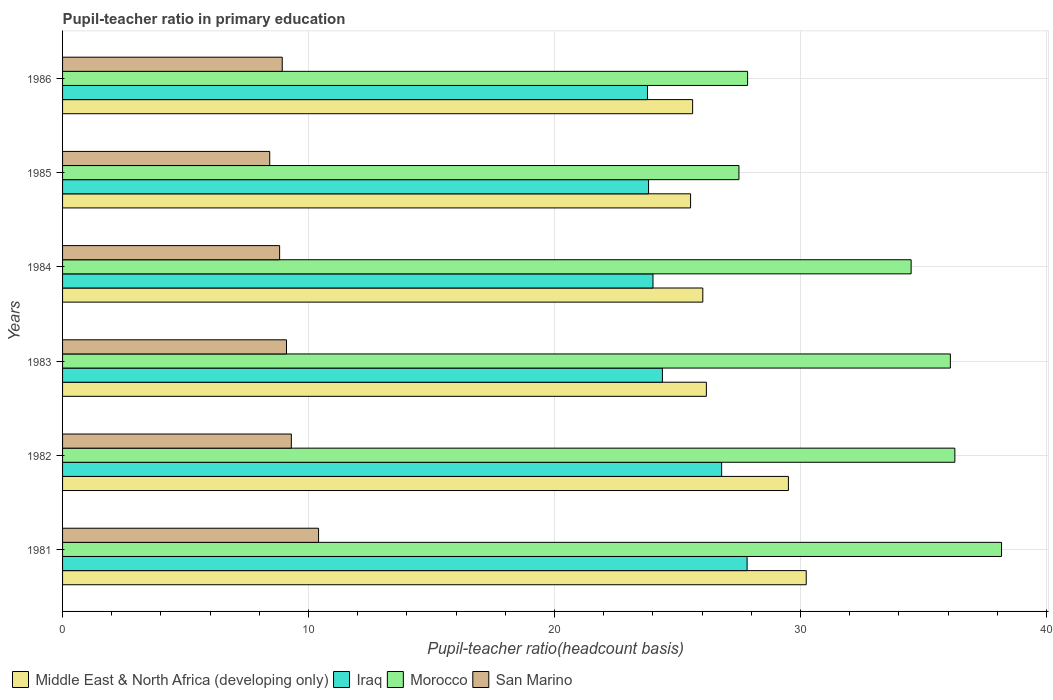How many different coloured bars are there?
Offer a terse response. 4. Are the number of bars per tick equal to the number of legend labels?
Your answer should be compact. Yes. Are the number of bars on each tick of the Y-axis equal?
Your answer should be compact. Yes. In how many cases, is the number of bars for a given year not equal to the number of legend labels?
Keep it short and to the point. 0. What is the pupil-teacher ratio in primary education in Morocco in 1986?
Keep it short and to the point. 27.85. Across all years, what is the maximum pupil-teacher ratio in primary education in San Marino?
Provide a succinct answer. 10.41. Across all years, what is the minimum pupil-teacher ratio in primary education in Morocco?
Make the answer very short. 27.5. What is the total pupil-teacher ratio in primary education in Middle East & North Africa (developing only) in the graph?
Your response must be concise. 163.08. What is the difference between the pupil-teacher ratio in primary education in Iraq in 1982 and that in 1983?
Your answer should be very brief. 2.41. What is the difference between the pupil-teacher ratio in primary education in Iraq in 1981 and the pupil-teacher ratio in primary education in Middle East & North Africa (developing only) in 1986?
Offer a terse response. 2.22. What is the average pupil-teacher ratio in primary education in Iraq per year?
Ensure brevity in your answer.  25.1. In the year 1981, what is the difference between the pupil-teacher ratio in primary education in Morocco and pupil-teacher ratio in primary education in Middle East & North Africa (developing only)?
Ensure brevity in your answer.  7.94. What is the ratio of the pupil-teacher ratio in primary education in Iraq in 1981 to that in 1985?
Give a very brief answer. 1.17. Is the pupil-teacher ratio in primary education in Morocco in 1984 less than that in 1986?
Give a very brief answer. No. What is the difference between the highest and the second highest pupil-teacher ratio in primary education in San Marino?
Offer a terse response. 1.11. What is the difference between the highest and the lowest pupil-teacher ratio in primary education in Morocco?
Keep it short and to the point. 10.68. In how many years, is the pupil-teacher ratio in primary education in Iraq greater than the average pupil-teacher ratio in primary education in Iraq taken over all years?
Make the answer very short. 2. Is the sum of the pupil-teacher ratio in primary education in San Marino in 1981 and 1983 greater than the maximum pupil-teacher ratio in primary education in Middle East & North Africa (developing only) across all years?
Provide a short and direct response. No. What does the 3rd bar from the top in 1982 represents?
Your response must be concise. Iraq. What does the 1st bar from the bottom in 1985 represents?
Provide a short and direct response. Middle East & North Africa (developing only). What is the difference between two consecutive major ticks on the X-axis?
Give a very brief answer. 10. Does the graph contain grids?
Give a very brief answer. Yes. How are the legend labels stacked?
Give a very brief answer. Horizontal. What is the title of the graph?
Give a very brief answer. Pupil-teacher ratio in primary education. What is the label or title of the X-axis?
Offer a very short reply. Pupil-teacher ratio(headcount basis). What is the Pupil-teacher ratio(headcount basis) in Middle East & North Africa (developing only) in 1981?
Provide a succinct answer. 30.23. What is the Pupil-teacher ratio(headcount basis) in Iraq in 1981?
Your answer should be very brief. 27.83. What is the Pupil-teacher ratio(headcount basis) in Morocco in 1981?
Ensure brevity in your answer.  38.17. What is the Pupil-teacher ratio(headcount basis) in San Marino in 1981?
Provide a succinct answer. 10.41. What is the Pupil-teacher ratio(headcount basis) in Middle East & North Africa (developing only) in 1982?
Ensure brevity in your answer.  29.51. What is the Pupil-teacher ratio(headcount basis) of Iraq in 1982?
Offer a terse response. 26.79. What is the Pupil-teacher ratio(headcount basis) of Morocco in 1982?
Your response must be concise. 36.27. What is the Pupil-teacher ratio(headcount basis) in San Marino in 1982?
Provide a short and direct response. 9.3. What is the Pupil-teacher ratio(headcount basis) of Middle East & North Africa (developing only) in 1983?
Your response must be concise. 26.17. What is the Pupil-teacher ratio(headcount basis) in Iraq in 1983?
Give a very brief answer. 24.39. What is the Pupil-teacher ratio(headcount basis) of Morocco in 1983?
Ensure brevity in your answer.  36.09. What is the Pupil-teacher ratio(headcount basis) of San Marino in 1983?
Give a very brief answer. 9.1. What is the Pupil-teacher ratio(headcount basis) in Middle East & North Africa (developing only) in 1984?
Offer a terse response. 26.03. What is the Pupil-teacher ratio(headcount basis) in Iraq in 1984?
Offer a very short reply. 24. What is the Pupil-teacher ratio(headcount basis) of Morocco in 1984?
Your answer should be very brief. 34.5. What is the Pupil-teacher ratio(headcount basis) in San Marino in 1984?
Ensure brevity in your answer.  8.82. What is the Pupil-teacher ratio(headcount basis) in Middle East & North Africa (developing only) in 1985?
Your answer should be very brief. 25.53. What is the Pupil-teacher ratio(headcount basis) of Iraq in 1985?
Give a very brief answer. 23.82. What is the Pupil-teacher ratio(headcount basis) in Morocco in 1985?
Give a very brief answer. 27.5. What is the Pupil-teacher ratio(headcount basis) of San Marino in 1985?
Offer a very short reply. 8.42. What is the Pupil-teacher ratio(headcount basis) in Middle East & North Africa (developing only) in 1986?
Provide a succinct answer. 25.61. What is the Pupil-teacher ratio(headcount basis) of Iraq in 1986?
Provide a short and direct response. 23.78. What is the Pupil-teacher ratio(headcount basis) in Morocco in 1986?
Give a very brief answer. 27.85. What is the Pupil-teacher ratio(headcount basis) of San Marino in 1986?
Your answer should be compact. 8.93. Across all years, what is the maximum Pupil-teacher ratio(headcount basis) of Middle East & North Africa (developing only)?
Your answer should be very brief. 30.23. Across all years, what is the maximum Pupil-teacher ratio(headcount basis) in Iraq?
Make the answer very short. 27.83. Across all years, what is the maximum Pupil-teacher ratio(headcount basis) in Morocco?
Make the answer very short. 38.17. Across all years, what is the maximum Pupil-teacher ratio(headcount basis) of San Marino?
Your response must be concise. 10.41. Across all years, what is the minimum Pupil-teacher ratio(headcount basis) of Middle East & North Africa (developing only)?
Give a very brief answer. 25.53. Across all years, what is the minimum Pupil-teacher ratio(headcount basis) of Iraq?
Ensure brevity in your answer.  23.78. Across all years, what is the minimum Pupil-teacher ratio(headcount basis) of Morocco?
Your answer should be very brief. 27.5. Across all years, what is the minimum Pupil-teacher ratio(headcount basis) in San Marino?
Offer a terse response. 8.42. What is the total Pupil-teacher ratio(headcount basis) of Middle East & North Africa (developing only) in the graph?
Provide a succinct answer. 163.08. What is the total Pupil-teacher ratio(headcount basis) of Iraq in the graph?
Keep it short and to the point. 150.61. What is the total Pupil-teacher ratio(headcount basis) in Morocco in the graph?
Offer a very short reply. 200.38. What is the total Pupil-teacher ratio(headcount basis) in San Marino in the graph?
Make the answer very short. 54.99. What is the difference between the Pupil-teacher ratio(headcount basis) in Middle East & North Africa (developing only) in 1981 and that in 1982?
Offer a very short reply. 0.72. What is the difference between the Pupil-teacher ratio(headcount basis) in Iraq in 1981 and that in 1982?
Offer a terse response. 1.04. What is the difference between the Pupil-teacher ratio(headcount basis) of Morocco in 1981 and that in 1982?
Your answer should be very brief. 1.9. What is the difference between the Pupil-teacher ratio(headcount basis) of San Marino in 1981 and that in 1982?
Give a very brief answer. 1.11. What is the difference between the Pupil-teacher ratio(headcount basis) of Middle East & North Africa (developing only) in 1981 and that in 1983?
Give a very brief answer. 4.06. What is the difference between the Pupil-teacher ratio(headcount basis) of Iraq in 1981 and that in 1983?
Your answer should be compact. 3.44. What is the difference between the Pupil-teacher ratio(headcount basis) of Morocco in 1981 and that in 1983?
Ensure brevity in your answer.  2.08. What is the difference between the Pupil-teacher ratio(headcount basis) of San Marino in 1981 and that in 1983?
Keep it short and to the point. 1.3. What is the difference between the Pupil-teacher ratio(headcount basis) in Middle East & North Africa (developing only) in 1981 and that in 1984?
Your response must be concise. 4.2. What is the difference between the Pupil-teacher ratio(headcount basis) of Iraq in 1981 and that in 1984?
Keep it short and to the point. 3.83. What is the difference between the Pupil-teacher ratio(headcount basis) of Morocco in 1981 and that in 1984?
Make the answer very short. 3.68. What is the difference between the Pupil-teacher ratio(headcount basis) of San Marino in 1981 and that in 1984?
Your answer should be compact. 1.58. What is the difference between the Pupil-teacher ratio(headcount basis) of Middle East & North Africa (developing only) in 1981 and that in 1985?
Ensure brevity in your answer.  4.7. What is the difference between the Pupil-teacher ratio(headcount basis) in Iraq in 1981 and that in 1985?
Make the answer very short. 4.01. What is the difference between the Pupil-teacher ratio(headcount basis) in Morocco in 1981 and that in 1985?
Offer a very short reply. 10.68. What is the difference between the Pupil-teacher ratio(headcount basis) in San Marino in 1981 and that in 1985?
Give a very brief answer. 1.99. What is the difference between the Pupil-teacher ratio(headcount basis) of Middle East & North Africa (developing only) in 1981 and that in 1986?
Provide a short and direct response. 4.62. What is the difference between the Pupil-teacher ratio(headcount basis) of Iraq in 1981 and that in 1986?
Keep it short and to the point. 4.05. What is the difference between the Pupil-teacher ratio(headcount basis) of Morocco in 1981 and that in 1986?
Your response must be concise. 10.32. What is the difference between the Pupil-teacher ratio(headcount basis) of San Marino in 1981 and that in 1986?
Offer a terse response. 1.48. What is the difference between the Pupil-teacher ratio(headcount basis) in Middle East & North Africa (developing only) in 1982 and that in 1983?
Provide a succinct answer. 3.33. What is the difference between the Pupil-teacher ratio(headcount basis) in Iraq in 1982 and that in 1983?
Offer a terse response. 2.41. What is the difference between the Pupil-teacher ratio(headcount basis) in Morocco in 1982 and that in 1983?
Ensure brevity in your answer.  0.18. What is the difference between the Pupil-teacher ratio(headcount basis) of San Marino in 1982 and that in 1983?
Your response must be concise. 0.2. What is the difference between the Pupil-teacher ratio(headcount basis) of Middle East & North Africa (developing only) in 1982 and that in 1984?
Keep it short and to the point. 3.48. What is the difference between the Pupil-teacher ratio(headcount basis) of Iraq in 1982 and that in 1984?
Your response must be concise. 2.79. What is the difference between the Pupil-teacher ratio(headcount basis) of Morocco in 1982 and that in 1984?
Keep it short and to the point. 1.78. What is the difference between the Pupil-teacher ratio(headcount basis) in San Marino in 1982 and that in 1984?
Provide a short and direct response. 0.48. What is the difference between the Pupil-teacher ratio(headcount basis) in Middle East & North Africa (developing only) in 1982 and that in 1985?
Your response must be concise. 3.98. What is the difference between the Pupil-teacher ratio(headcount basis) of Iraq in 1982 and that in 1985?
Your answer should be very brief. 2.97. What is the difference between the Pupil-teacher ratio(headcount basis) in Morocco in 1982 and that in 1985?
Give a very brief answer. 8.78. What is the difference between the Pupil-teacher ratio(headcount basis) of San Marino in 1982 and that in 1985?
Provide a succinct answer. 0.88. What is the difference between the Pupil-teacher ratio(headcount basis) in Middle East & North Africa (developing only) in 1982 and that in 1986?
Offer a very short reply. 3.89. What is the difference between the Pupil-teacher ratio(headcount basis) in Iraq in 1982 and that in 1986?
Offer a terse response. 3.01. What is the difference between the Pupil-teacher ratio(headcount basis) of Morocco in 1982 and that in 1986?
Keep it short and to the point. 8.42. What is the difference between the Pupil-teacher ratio(headcount basis) of San Marino in 1982 and that in 1986?
Offer a very short reply. 0.37. What is the difference between the Pupil-teacher ratio(headcount basis) in Middle East & North Africa (developing only) in 1983 and that in 1984?
Your answer should be compact. 0.15. What is the difference between the Pupil-teacher ratio(headcount basis) of Iraq in 1983 and that in 1984?
Offer a terse response. 0.38. What is the difference between the Pupil-teacher ratio(headcount basis) in Morocco in 1983 and that in 1984?
Make the answer very short. 1.6. What is the difference between the Pupil-teacher ratio(headcount basis) in San Marino in 1983 and that in 1984?
Your response must be concise. 0.28. What is the difference between the Pupil-teacher ratio(headcount basis) in Middle East & North Africa (developing only) in 1983 and that in 1985?
Keep it short and to the point. 0.64. What is the difference between the Pupil-teacher ratio(headcount basis) in Iraq in 1983 and that in 1985?
Offer a very short reply. 0.56. What is the difference between the Pupil-teacher ratio(headcount basis) in Morocco in 1983 and that in 1985?
Provide a short and direct response. 8.59. What is the difference between the Pupil-teacher ratio(headcount basis) in San Marino in 1983 and that in 1985?
Make the answer very short. 0.68. What is the difference between the Pupil-teacher ratio(headcount basis) of Middle East & North Africa (developing only) in 1983 and that in 1986?
Your answer should be compact. 0.56. What is the difference between the Pupil-teacher ratio(headcount basis) in Iraq in 1983 and that in 1986?
Give a very brief answer. 0.61. What is the difference between the Pupil-teacher ratio(headcount basis) in Morocco in 1983 and that in 1986?
Offer a very short reply. 8.24. What is the difference between the Pupil-teacher ratio(headcount basis) of San Marino in 1983 and that in 1986?
Ensure brevity in your answer.  0.17. What is the difference between the Pupil-teacher ratio(headcount basis) of Middle East & North Africa (developing only) in 1984 and that in 1985?
Your answer should be compact. 0.5. What is the difference between the Pupil-teacher ratio(headcount basis) in Iraq in 1984 and that in 1985?
Offer a terse response. 0.18. What is the difference between the Pupil-teacher ratio(headcount basis) of Morocco in 1984 and that in 1985?
Your answer should be very brief. 7. What is the difference between the Pupil-teacher ratio(headcount basis) of San Marino in 1984 and that in 1985?
Keep it short and to the point. 0.4. What is the difference between the Pupil-teacher ratio(headcount basis) of Middle East & North Africa (developing only) in 1984 and that in 1986?
Keep it short and to the point. 0.41. What is the difference between the Pupil-teacher ratio(headcount basis) of Iraq in 1984 and that in 1986?
Make the answer very short. 0.22. What is the difference between the Pupil-teacher ratio(headcount basis) in Morocco in 1984 and that in 1986?
Offer a terse response. 6.65. What is the difference between the Pupil-teacher ratio(headcount basis) in San Marino in 1984 and that in 1986?
Provide a short and direct response. -0.11. What is the difference between the Pupil-teacher ratio(headcount basis) in Middle East & North Africa (developing only) in 1985 and that in 1986?
Your answer should be compact. -0.08. What is the difference between the Pupil-teacher ratio(headcount basis) of Iraq in 1985 and that in 1986?
Provide a succinct answer. 0.04. What is the difference between the Pupil-teacher ratio(headcount basis) in Morocco in 1985 and that in 1986?
Your answer should be very brief. -0.35. What is the difference between the Pupil-teacher ratio(headcount basis) of San Marino in 1985 and that in 1986?
Give a very brief answer. -0.51. What is the difference between the Pupil-teacher ratio(headcount basis) of Middle East & North Africa (developing only) in 1981 and the Pupil-teacher ratio(headcount basis) of Iraq in 1982?
Give a very brief answer. 3.44. What is the difference between the Pupil-teacher ratio(headcount basis) in Middle East & North Africa (developing only) in 1981 and the Pupil-teacher ratio(headcount basis) in Morocco in 1982?
Offer a terse response. -6.04. What is the difference between the Pupil-teacher ratio(headcount basis) of Middle East & North Africa (developing only) in 1981 and the Pupil-teacher ratio(headcount basis) of San Marino in 1982?
Keep it short and to the point. 20.93. What is the difference between the Pupil-teacher ratio(headcount basis) of Iraq in 1981 and the Pupil-teacher ratio(headcount basis) of Morocco in 1982?
Make the answer very short. -8.44. What is the difference between the Pupil-teacher ratio(headcount basis) of Iraq in 1981 and the Pupil-teacher ratio(headcount basis) of San Marino in 1982?
Your answer should be very brief. 18.53. What is the difference between the Pupil-teacher ratio(headcount basis) in Morocco in 1981 and the Pupil-teacher ratio(headcount basis) in San Marino in 1982?
Offer a very short reply. 28.87. What is the difference between the Pupil-teacher ratio(headcount basis) of Middle East & North Africa (developing only) in 1981 and the Pupil-teacher ratio(headcount basis) of Iraq in 1983?
Make the answer very short. 5.85. What is the difference between the Pupil-teacher ratio(headcount basis) of Middle East & North Africa (developing only) in 1981 and the Pupil-teacher ratio(headcount basis) of Morocco in 1983?
Offer a terse response. -5.86. What is the difference between the Pupil-teacher ratio(headcount basis) of Middle East & North Africa (developing only) in 1981 and the Pupil-teacher ratio(headcount basis) of San Marino in 1983?
Provide a short and direct response. 21.13. What is the difference between the Pupil-teacher ratio(headcount basis) of Iraq in 1981 and the Pupil-teacher ratio(headcount basis) of Morocco in 1983?
Provide a succinct answer. -8.26. What is the difference between the Pupil-teacher ratio(headcount basis) of Iraq in 1981 and the Pupil-teacher ratio(headcount basis) of San Marino in 1983?
Make the answer very short. 18.73. What is the difference between the Pupil-teacher ratio(headcount basis) in Morocco in 1981 and the Pupil-teacher ratio(headcount basis) in San Marino in 1983?
Offer a terse response. 29.07. What is the difference between the Pupil-teacher ratio(headcount basis) of Middle East & North Africa (developing only) in 1981 and the Pupil-teacher ratio(headcount basis) of Iraq in 1984?
Your answer should be compact. 6.23. What is the difference between the Pupil-teacher ratio(headcount basis) of Middle East & North Africa (developing only) in 1981 and the Pupil-teacher ratio(headcount basis) of Morocco in 1984?
Ensure brevity in your answer.  -4.26. What is the difference between the Pupil-teacher ratio(headcount basis) in Middle East & North Africa (developing only) in 1981 and the Pupil-teacher ratio(headcount basis) in San Marino in 1984?
Provide a short and direct response. 21.41. What is the difference between the Pupil-teacher ratio(headcount basis) of Iraq in 1981 and the Pupil-teacher ratio(headcount basis) of Morocco in 1984?
Offer a very short reply. -6.67. What is the difference between the Pupil-teacher ratio(headcount basis) of Iraq in 1981 and the Pupil-teacher ratio(headcount basis) of San Marino in 1984?
Your answer should be very brief. 19. What is the difference between the Pupil-teacher ratio(headcount basis) of Morocco in 1981 and the Pupil-teacher ratio(headcount basis) of San Marino in 1984?
Provide a succinct answer. 29.35. What is the difference between the Pupil-teacher ratio(headcount basis) in Middle East & North Africa (developing only) in 1981 and the Pupil-teacher ratio(headcount basis) in Iraq in 1985?
Provide a short and direct response. 6.41. What is the difference between the Pupil-teacher ratio(headcount basis) in Middle East & North Africa (developing only) in 1981 and the Pupil-teacher ratio(headcount basis) in Morocco in 1985?
Keep it short and to the point. 2.74. What is the difference between the Pupil-teacher ratio(headcount basis) in Middle East & North Africa (developing only) in 1981 and the Pupil-teacher ratio(headcount basis) in San Marino in 1985?
Give a very brief answer. 21.81. What is the difference between the Pupil-teacher ratio(headcount basis) of Iraq in 1981 and the Pupil-teacher ratio(headcount basis) of Morocco in 1985?
Ensure brevity in your answer.  0.33. What is the difference between the Pupil-teacher ratio(headcount basis) in Iraq in 1981 and the Pupil-teacher ratio(headcount basis) in San Marino in 1985?
Ensure brevity in your answer.  19.41. What is the difference between the Pupil-teacher ratio(headcount basis) in Morocco in 1981 and the Pupil-teacher ratio(headcount basis) in San Marino in 1985?
Ensure brevity in your answer.  29.75. What is the difference between the Pupil-teacher ratio(headcount basis) in Middle East & North Africa (developing only) in 1981 and the Pupil-teacher ratio(headcount basis) in Iraq in 1986?
Keep it short and to the point. 6.45. What is the difference between the Pupil-teacher ratio(headcount basis) in Middle East & North Africa (developing only) in 1981 and the Pupil-teacher ratio(headcount basis) in Morocco in 1986?
Give a very brief answer. 2.38. What is the difference between the Pupil-teacher ratio(headcount basis) of Middle East & North Africa (developing only) in 1981 and the Pupil-teacher ratio(headcount basis) of San Marino in 1986?
Keep it short and to the point. 21.3. What is the difference between the Pupil-teacher ratio(headcount basis) in Iraq in 1981 and the Pupil-teacher ratio(headcount basis) in Morocco in 1986?
Your answer should be compact. -0.02. What is the difference between the Pupil-teacher ratio(headcount basis) of Iraq in 1981 and the Pupil-teacher ratio(headcount basis) of San Marino in 1986?
Provide a short and direct response. 18.9. What is the difference between the Pupil-teacher ratio(headcount basis) of Morocco in 1981 and the Pupil-teacher ratio(headcount basis) of San Marino in 1986?
Your answer should be compact. 29.24. What is the difference between the Pupil-teacher ratio(headcount basis) in Middle East & North Africa (developing only) in 1982 and the Pupil-teacher ratio(headcount basis) in Iraq in 1983?
Keep it short and to the point. 5.12. What is the difference between the Pupil-teacher ratio(headcount basis) in Middle East & North Africa (developing only) in 1982 and the Pupil-teacher ratio(headcount basis) in Morocco in 1983?
Your response must be concise. -6.58. What is the difference between the Pupil-teacher ratio(headcount basis) of Middle East & North Africa (developing only) in 1982 and the Pupil-teacher ratio(headcount basis) of San Marino in 1983?
Provide a short and direct response. 20.4. What is the difference between the Pupil-teacher ratio(headcount basis) of Iraq in 1982 and the Pupil-teacher ratio(headcount basis) of Morocco in 1983?
Offer a very short reply. -9.3. What is the difference between the Pupil-teacher ratio(headcount basis) of Iraq in 1982 and the Pupil-teacher ratio(headcount basis) of San Marino in 1983?
Your answer should be compact. 17.69. What is the difference between the Pupil-teacher ratio(headcount basis) in Morocco in 1982 and the Pupil-teacher ratio(headcount basis) in San Marino in 1983?
Provide a short and direct response. 27.17. What is the difference between the Pupil-teacher ratio(headcount basis) in Middle East & North Africa (developing only) in 1982 and the Pupil-teacher ratio(headcount basis) in Iraq in 1984?
Make the answer very short. 5.51. What is the difference between the Pupil-teacher ratio(headcount basis) in Middle East & North Africa (developing only) in 1982 and the Pupil-teacher ratio(headcount basis) in Morocco in 1984?
Offer a terse response. -4.99. What is the difference between the Pupil-teacher ratio(headcount basis) in Middle East & North Africa (developing only) in 1982 and the Pupil-teacher ratio(headcount basis) in San Marino in 1984?
Your answer should be very brief. 20.68. What is the difference between the Pupil-teacher ratio(headcount basis) of Iraq in 1982 and the Pupil-teacher ratio(headcount basis) of Morocco in 1984?
Keep it short and to the point. -7.7. What is the difference between the Pupil-teacher ratio(headcount basis) of Iraq in 1982 and the Pupil-teacher ratio(headcount basis) of San Marino in 1984?
Ensure brevity in your answer.  17.97. What is the difference between the Pupil-teacher ratio(headcount basis) in Morocco in 1982 and the Pupil-teacher ratio(headcount basis) in San Marino in 1984?
Make the answer very short. 27.45. What is the difference between the Pupil-teacher ratio(headcount basis) of Middle East & North Africa (developing only) in 1982 and the Pupil-teacher ratio(headcount basis) of Iraq in 1985?
Ensure brevity in your answer.  5.69. What is the difference between the Pupil-teacher ratio(headcount basis) of Middle East & North Africa (developing only) in 1982 and the Pupil-teacher ratio(headcount basis) of Morocco in 1985?
Ensure brevity in your answer.  2.01. What is the difference between the Pupil-teacher ratio(headcount basis) of Middle East & North Africa (developing only) in 1982 and the Pupil-teacher ratio(headcount basis) of San Marino in 1985?
Offer a very short reply. 21.09. What is the difference between the Pupil-teacher ratio(headcount basis) of Iraq in 1982 and the Pupil-teacher ratio(headcount basis) of Morocco in 1985?
Provide a succinct answer. -0.7. What is the difference between the Pupil-teacher ratio(headcount basis) in Iraq in 1982 and the Pupil-teacher ratio(headcount basis) in San Marino in 1985?
Your response must be concise. 18.37. What is the difference between the Pupil-teacher ratio(headcount basis) in Morocco in 1982 and the Pupil-teacher ratio(headcount basis) in San Marino in 1985?
Your response must be concise. 27.85. What is the difference between the Pupil-teacher ratio(headcount basis) of Middle East & North Africa (developing only) in 1982 and the Pupil-teacher ratio(headcount basis) of Iraq in 1986?
Ensure brevity in your answer.  5.73. What is the difference between the Pupil-teacher ratio(headcount basis) of Middle East & North Africa (developing only) in 1982 and the Pupil-teacher ratio(headcount basis) of Morocco in 1986?
Ensure brevity in your answer.  1.66. What is the difference between the Pupil-teacher ratio(headcount basis) of Middle East & North Africa (developing only) in 1982 and the Pupil-teacher ratio(headcount basis) of San Marino in 1986?
Offer a very short reply. 20.58. What is the difference between the Pupil-teacher ratio(headcount basis) in Iraq in 1982 and the Pupil-teacher ratio(headcount basis) in Morocco in 1986?
Offer a terse response. -1.06. What is the difference between the Pupil-teacher ratio(headcount basis) of Iraq in 1982 and the Pupil-teacher ratio(headcount basis) of San Marino in 1986?
Your answer should be very brief. 17.86. What is the difference between the Pupil-teacher ratio(headcount basis) in Morocco in 1982 and the Pupil-teacher ratio(headcount basis) in San Marino in 1986?
Your response must be concise. 27.34. What is the difference between the Pupil-teacher ratio(headcount basis) of Middle East & North Africa (developing only) in 1983 and the Pupil-teacher ratio(headcount basis) of Iraq in 1984?
Offer a terse response. 2.17. What is the difference between the Pupil-teacher ratio(headcount basis) of Middle East & North Africa (developing only) in 1983 and the Pupil-teacher ratio(headcount basis) of Morocco in 1984?
Keep it short and to the point. -8.32. What is the difference between the Pupil-teacher ratio(headcount basis) of Middle East & North Africa (developing only) in 1983 and the Pupil-teacher ratio(headcount basis) of San Marino in 1984?
Give a very brief answer. 17.35. What is the difference between the Pupil-teacher ratio(headcount basis) of Iraq in 1983 and the Pupil-teacher ratio(headcount basis) of Morocco in 1984?
Offer a terse response. -10.11. What is the difference between the Pupil-teacher ratio(headcount basis) in Iraq in 1983 and the Pupil-teacher ratio(headcount basis) in San Marino in 1984?
Keep it short and to the point. 15.56. What is the difference between the Pupil-teacher ratio(headcount basis) of Morocco in 1983 and the Pupil-teacher ratio(headcount basis) of San Marino in 1984?
Provide a succinct answer. 27.27. What is the difference between the Pupil-teacher ratio(headcount basis) in Middle East & North Africa (developing only) in 1983 and the Pupil-teacher ratio(headcount basis) in Iraq in 1985?
Your answer should be very brief. 2.35. What is the difference between the Pupil-teacher ratio(headcount basis) of Middle East & North Africa (developing only) in 1983 and the Pupil-teacher ratio(headcount basis) of Morocco in 1985?
Provide a short and direct response. -1.32. What is the difference between the Pupil-teacher ratio(headcount basis) in Middle East & North Africa (developing only) in 1983 and the Pupil-teacher ratio(headcount basis) in San Marino in 1985?
Ensure brevity in your answer.  17.75. What is the difference between the Pupil-teacher ratio(headcount basis) of Iraq in 1983 and the Pupil-teacher ratio(headcount basis) of Morocco in 1985?
Offer a terse response. -3.11. What is the difference between the Pupil-teacher ratio(headcount basis) of Iraq in 1983 and the Pupil-teacher ratio(headcount basis) of San Marino in 1985?
Your response must be concise. 15.96. What is the difference between the Pupil-teacher ratio(headcount basis) in Morocco in 1983 and the Pupil-teacher ratio(headcount basis) in San Marino in 1985?
Give a very brief answer. 27.67. What is the difference between the Pupil-teacher ratio(headcount basis) of Middle East & North Africa (developing only) in 1983 and the Pupil-teacher ratio(headcount basis) of Iraq in 1986?
Your response must be concise. 2.39. What is the difference between the Pupil-teacher ratio(headcount basis) of Middle East & North Africa (developing only) in 1983 and the Pupil-teacher ratio(headcount basis) of Morocco in 1986?
Provide a succinct answer. -1.68. What is the difference between the Pupil-teacher ratio(headcount basis) of Middle East & North Africa (developing only) in 1983 and the Pupil-teacher ratio(headcount basis) of San Marino in 1986?
Ensure brevity in your answer.  17.24. What is the difference between the Pupil-teacher ratio(headcount basis) in Iraq in 1983 and the Pupil-teacher ratio(headcount basis) in Morocco in 1986?
Ensure brevity in your answer.  -3.46. What is the difference between the Pupil-teacher ratio(headcount basis) of Iraq in 1983 and the Pupil-teacher ratio(headcount basis) of San Marino in 1986?
Your answer should be compact. 15.45. What is the difference between the Pupil-teacher ratio(headcount basis) in Morocco in 1983 and the Pupil-teacher ratio(headcount basis) in San Marino in 1986?
Your answer should be compact. 27.16. What is the difference between the Pupil-teacher ratio(headcount basis) in Middle East & North Africa (developing only) in 1984 and the Pupil-teacher ratio(headcount basis) in Iraq in 1985?
Keep it short and to the point. 2.21. What is the difference between the Pupil-teacher ratio(headcount basis) in Middle East & North Africa (developing only) in 1984 and the Pupil-teacher ratio(headcount basis) in Morocco in 1985?
Provide a succinct answer. -1.47. What is the difference between the Pupil-teacher ratio(headcount basis) of Middle East & North Africa (developing only) in 1984 and the Pupil-teacher ratio(headcount basis) of San Marino in 1985?
Make the answer very short. 17.61. What is the difference between the Pupil-teacher ratio(headcount basis) in Iraq in 1984 and the Pupil-teacher ratio(headcount basis) in Morocco in 1985?
Your answer should be very brief. -3.49. What is the difference between the Pupil-teacher ratio(headcount basis) of Iraq in 1984 and the Pupil-teacher ratio(headcount basis) of San Marino in 1985?
Your answer should be compact. 15.58. What is the difference between the Pupil-teacher ratio(headcount basis) of Morocco in 1984 and the Pupil-teacher ratio(headcount basis) of San Marino in 1985?
Your answer should be compact. 26.07. What is the difference between the Pupil-teacher ratio(headcount basis) in Middle East & North Africa (developing only) in 1984 and the Pupil-teacher ratio(headcount basis) in Iraq in 1986?
Give a very brief answer. 2.25. What is the difference between the Pupil-teacher ratio(headcount basis) in Middle East & North Africa (developing only) in 1984 and the Pupil-teacher ratio(headcount basis) in Morocco in 1986?
Your answer should be compact. -1.82. What is the difference between the Pupil-teacher ratio(headcount basis) in Middle East & North Africa (developing only) in 1984 and the Pupil-teacher ratio(headcount basis) in San Marino in 1986?
Provide a succinct answer. 17.1. What is the difference between the Pupil-teacher ratio(headcount basis) in Iraq in 1984 and the Pupil-teacher ratio(headcount basis) in Morocco in 1986?
Make the answer very short. -3.85. What is the difference between the Pupil-teacher ratio(headcount basis) of Iraq in 1984 and the Pupil-teacher ratio(headcount basis) of San Marino in 1986?
Keep it short and to the point. 15.07. What is the difference between the Pupil-teacher ratio(headcount basis) in Morocco in 1984 and the Pupil-teacher ratio(headcount basis) in San Marino in 1986?
Provide a short and direct response. 25.57. What is the difference between the Pupil-teacher ratio(headcount basis) of Middle East & North Africa (developing only) in 1985 and the Pupil-teacher ratio(headcount basis) of Iraq in 1986?
Keep it short and to the point. 1.75. What is the difference between the Pupil-teacher ratio(headcount basis) in Middle East & North Africa (developing only) in 1985 and the Pupil-teacher ratio(headcount basis) in Morocco in 1986?
Make the answer very short. -2.32. What is the difference between the Pupil-teacher ratio(headcount basis) in Middle East & North Africa (developing only) in 1985 and the Pupil-teacher ratio(headcount basis) in San Marino in 1986?
Ensure brevity in your answer.  16.6. What is the difference between the Pupil-teacher ratio(headcount basis) of Iraq in 1985 and the Pupil-teacher ratio(headcount basis) of Morocco in 1986?
Keep it short and to the point. -4.03. What is the difference between the Pupil-teacher ratio(headcount basis) in Iraq in 1985 and the Pupil-teacher ratio(headcount basis) in San Marino in 1986?
Your response must be concise. 14.89. What is the difference between the Pupil-teacher ratio(headcount basis) of Morocco in 1985 and the Pupil-teacher ratio(headcount basis) of San Marino in 1986?
Your answer should be compact. 18.57. What is the average Pupil-teacher ratio(headcount basis) in Middle East & North Africa (developing only) per year?
Provide a short and direct response. 27.18. What is the average Pupil-teacher ratio(headcount basis) in Iraq per year?
Provide a short and direct response. 25.1. What is the average Pupil-teacher ratio(headcount basis) of Morocco per year?
Provide a succinct answer. 33.4. What is the average Pupil-teacher ratio(headcount basis) in San Marino per year?
Offer a terse response. 9.16. In the year 1981, what is the difference between the Pupil-teacher ratio(headcount basis) of Middle East & North Africa (developing only) and Pupil-teacher ratio(headcount basis) of Iraq?
Make the answer very short. 2.4. In the year 1981, what is the difference between the Pupil-teacher ratio(headcount basis) of Middle East & North Africa (developing only) and Pupil-teacher ratio(headcount basis) of Morocco?
Your response must be concise. -7.94. In the year 1981, what is the difference between the Pupil-teacher ratio(headcount basis) of Middle East & North Africa (developing only) and Pupil-teacher ratio(headcount basis) of San Marino?
Your answer should be very brief. 19.83. In the year 1981, what is the difference between the Pupil-teacher ratio(headcount basis) of Iraq and Pupil-teacher ratio(headcount basis) of Morocco?
Your response must be concise. -10.34. In the year 1981, what is the difference between the Pupil-teacher ratio(headcount basis) in Iraq and Pupil-teacher ratio(headcount basis) in San Marino?
Offer a very short reply. 17.42. In the year 1981, what is the difference between the Pupil-teacher ratio(headcount basis) in Morocco and Pupil-teacher ratio(headcount basis) in San Marino?
Your answer should be compact. 27.77. In the year 1982, what is the difference between the Pupil-teacher ratio(headcount basis) of Middle East & North Africa (developing only) and Pupil-teacher ratio(headcount basis) of Iraq?
Make the answer very short. 2.71. In the year 1982, what is the difference between the Pupil-teacher ratio(headcount basis) of Middle East & North Africa (developing only) and Pupil-teacher ratio(headcount basis) of Morocco?
Offer a very short reply. -6.77. In the year 1982, what is the difference between the Pupil-teacher ratio(headcount basis) of Middle East & North Africa (developing only) and Pupil-teacher ratio(headcount basis) of San Marino?
Keep it short and to the point. 20.21. In the year 1982, what is the difference between the Pupil-teacher ratio(headcount basis) of Iraq and Pupil-teacher ratio(headcount basis) of Morocco?
Your answer should be very brief. -9.48. In the year 1982, what is the difference between the Pupil-teacher ratio(headcount basis) in Iraq and Pupil-teacher ratio(headcount basis) in San Marino?
Offer a very short reply. 17.49. In the year 1982, what is the difference between the Pupil-teacher ratio(headcount basis) of Morocco and Pupil-teacher ratio(headcount basis) of San Marino?
Your response must be concise. 26.97. In the year 1983, what is the difference between the Pupil-teacher ratio(headcount basis) of Middle East & North Africa (developing only) and Pupil-teacher ratio(headcount basis) of Iraq?
Your answer should be compact. 1.79. In the year 1983, what is the difference between the Pupil-teacher ratio(headcount basis) in Middle East & North Africa (developing only) and Pupil-teacher ratio(headcount basis) in Morocco?
Ensure brevity in your answer.  -9.92. In the year 1983, what is the difference between the Pupil-teacher ratio(headcount basis) of Middle East & North Africa (developing only) and Pupil-teacher ratio(headcount basis) of San Marino?
Your answer should be compact. 17.07. In the year 1983, what is the difference between the Pupil-teacher ratio(headcount basis) in Iraq and Pupil-teacher ratio(headcount basis) in Morocco?
Your answer should be compact. -11.71. In the year 1983, what is the difference between the Pupil-teacher ratio(headcount basis) in Iraq and Pupil-teacher ratio(headcount basis) in San Marino?
Your answer should be very brief. 15.28. In the year 1983, what is the difference between the Pupil-teacher ratio(headcount basis) in Morocco and Pupil-teacher ratio(headcount basis) in San Marino?
Keep it short and to the point. 26.99. In the year 1984, what is the difference between the Pupil-teacher ratio(headcount basis) of Middle East & North Africa (developing only) and Pupil-teacher ratio(headcount basis) of Iraq?
Offer a very short reply. 2.03. In the year 1984, what is the difference between the Pupil-teacher ratio(headcount basis) in Middle East & North Africa (developing only) and Pupil-teacher ratio(headcount basis) in Morocco?
Offer a very short reply. -8.47. In the year 1984, what is the difference between the Pupil-teacher ratio(headcount basis) of Middle East & North Africa (developing only) and Pupil-teacher ratio(headcount basis) of San Marino?
Your answer should be compact. 17.2. In the year 1984, what is the difference between the Pupil-teacher ratio(headcount basis) in Iraq and Pupil-teacher ratio(headcount basis) in Morocco?
Provide a succinct answer. -10.49. In the year 1984, what is the difference between the Pupil-teacher ratio(headcount basis) in Iraq and Pupil-teacher ratio(headcount basis) in San Marino?
Ensure brevity in your answer.  15.18. In the year 1984, what is the difference between the Pupil-teacher ratio(headcount basis) in Morocco and Pupil-teacher ratio(headcount basis) in San Marino?
Your response must be concise. 25.67. In the year 1985, what is the difference between the Pupil-teacher ratio(headcount basis) in Middle East & North Africa (developing only) and Pupil-teacher ratio(headcount basis) in Iraq?
Your answer should be compact. 1.71. In the year 1985, what is the difference between the Pupil-teacher ratio(headcount basis) in Middle East & North Africa (developing only) and Pupil-teacher ratio(headcount basis) in Morocco?
Offer a very short reply. -1.97. In the year 1985, what is the difference between the Pupil-teacher ratio(headcount basis) in Middle East & North Africa (developing only) and Pupil-teacher ratio(headcount basis) in San Marino?
Make the answer very short. 17.11. In the year 1985, what is the difference between the Pupil-teacher ratio(headcount basis) of Iraq and Pupil-teacher ratio(headcount basis) of Morocco?
Your response must be concise. -3.67. In the year 1985, what is the difference between the Pupil-teacher ratio(headcount basis) in Iraq and Pupil-teacher ratio(headcount basis) in San Marino?
Offer a terse response. 15.4. In the year 1985, what is the difference between the Pupil-teacher ratio(headcount basis) in Morocco and Pupil-teacher ratio(headcount basis) in San Marino?
Your response must be concise. 19.08. In the year 1986, what is the difference between the Pupil-teacher ratio(headcount basis) of Middle East & North Africa (developing only) and Pupil-teacher ratio(headcount basis) of Iraq?
Offer a terse response. 1.84. In the year 1986, what is the difference between the Pupil-teacher ratio(headcount basis) of Middle East & North Africa (developing only) and Pupil-teacher ratio(headcount basis) of Morocco?
Keep it short and to the point. -2.23. In the year 1986, what is the difference between the Pupil-teacher ratio(headcount basis) of Middle East & North Africa (developing only) and Pupil-teacher ratio(headcount basis) of San Marino?
Offer a terse response. 16.68. In the year 1986, what is the difference between the Pupil-teacher ratio(headcount basis) of Iraq and Pupil-teacher ratio(headcount basis) of Morocco?
Give a very brief answer. -4.07. In the year 1986, what is the difference between the Pupil-teacher ratio(headcount basis) of Iraq and Pupil-teacher ratio(headcount basis) of San Marino?
Keep it short and to the point. 14.85. In the year 1986, what is the difference between the Pupil-teacher ratio(headcount basis) in Morocco and Pupil-teacher ratio(headcount basis) in San Marino?
Your response must be concise. 18.92. What is the ratio of the Pupil-teacher ratio(headcount basis) of Middle East & North Africa (developing only) in 1981 to that in 1982?
Offer a terse response. 1.02. What is the ratio of the Pupil-teacher ratio(headcount basis) of Iraq in 1981 to that in 1982?
Your response must be concise. 1.04. What is the ratio of the Pupil-teacher ratio(headcount basis) in Morocco in 1981 to that in 1982?
Make the answer very short. 1.05. What is the ratio of the Pupil-teacher ratio(headcount basis) in San Marino in 1981 to that in 1982?
Provide a succinct answer. 1.12. What is the ratio of the Pupil-teacher ratio(headcount basis) in Middle East & North Africa (developing only) in 1981 to that in 1983?
Offer a terse response. 1.16. What is the ratio of the Pupil-teacher ratio(headcount basis) of Iraq in 1981 to that in 1983?
Your response must be concise. 1.14. What is the ratio of the Pupil-teacher ratio(headcount basis) in Morocco in 1981 to that in 1983?
Keep it short and to the point. 1.06. What is the ratio of the Pupil-teacher ratio(headcount basis) of San Marino in 1981 to that in 1983?
Make the answer very short. 1.14. What is the ratio of the Pupil-teacher ratio(headcount basis) of Middle East & North Africa (developing only) in 1981 to that in 1984?
Your answer should be very brief. 1.16. What is the ratio of the Pupil-teacher ratio(headcount basis) of Iraq in 1981 to that in 1984?
Offer a terse response. 1.16. What is the ratio of the Pupil-teacher ratio(headcount basis) of Morocco in 1981 to that in 1984?
Keep it short and to the point. 1.11. What is the ratio of the Pupil-teacher ratio(headcount basis) of San Marino in 1981 to that in 1984?
Provide a short and direct response. 1.18. What is the ratio of the Pupil-teacher ratio(headcount basis) of Middle East & North Africa (developing only) in 1981 to that in 1985?
Your answer should be very brief. 1.18. What is the ratio of the Pupil-teacher ratio(headcount basis) in Iraq in 1981 to that in 1985?
Provide a succinct answer. 1.17. What is the ratio of the Pupil-teacher ratio(headcount basis) of Morocco in 1981 to that in 1985?
Keep it short and to the point. 1.39. What is the ratio of the Pupil-teacher ratio(headcount basis) of San Marino in 1981 to that in 1985?
Make the answer very short. 1.24. What is the ratio of the Pupil-teacher ratio(headcount basis) in Middle East & North Africa (developing only) in 1981 to that in 1986?
Provide a succinct answer. 1.18. What is the ratio of the Pupil-teacher ratio(headcount basis) of Iraq in 1981 to that in 1986?
Your answer should be compact. 1.17. What is the ratio of the Pupil-teacher ratio(headcount basis) of Morocco in 1981 to that in 1986?
Make the answer very short. 1.37. What is the ratio of the Pupil-teacher ratio(headcount basis) in San Marino in 1981 to that in 1986?
Provide a short and direct response. 1.17. What is the ratio of the Pupil-teacher ratio(headcount basis) of Middle East & North Africa (developing only) in 1982 to that in 1983?
Ensure brevity in your answer.  1.13. What is the ratio of the Pupil-teacher ratio(headcount basis) in Iraq in 1982 to that in 1983?
Give a very brief answer. 1.1. What is the ratio of the Pupil-teacher ratio(headcount basis) of Morocco in 1982 to that in 1983?
Give a very brief answer. 1. What is the ratio of the Pupil-teacher ratio(headcount basis) in San Marino in 1982 to that in 1983?
Your answer should be very brief. 1.02. What is the ratio of the Pupil-teacher ratio(headcount basis) of Middle East & North Africa (developing only) in 1982 to that in 1984?
Offer a terse response. 1.13. What is the ratio of the Pupil-teacher ratio(headcount basis) in Iraq in 1982 to that in 1984?
Offer a terse response. 1.12. What is the ratio of the Pupil-teacher ratio(headcount basis) of Morocco in 1982 to that in 1984?
Provide a succinct answer. 1.05. What is the ratio of the Pupil-teacher ratio(headcount basis) of San Marino in 1982 to that in 1984?
Offer a very short reply. 1.05. What is the ratio of the Pupil-teacher ratio(headcount basis) of Middle East & North Africa (developing only) in 1982 to that in 1985?
Provide a short and direct response. 1.16. What is the ratio of the Pupil-teacher ratio(headcount basis) in Iraq in 1982 to that in 1985?
Give a very brief answer. 1.12. What is the ratio of the Pupil-teacher ratio(headcount basis) of Morocco in 1982 to that in 1985?
Your answer should be very brief. 1.32. What is the ratio of the Pupil-teacher ratio(headcount basis) of San Marino in 1982 to that in 1985?
Make the answer very short. 1.1. What is the ratio of the Pupil-teacher ratio(headcount basis) in Middle East & North Africa (developing only) in 1982 to that in 1986?
Provide a short and direct response. 1.15. What is the ratio of the Pupil-teacher ratio(headcount basis) of Iraq in 1982 to that in 1986?
Ensure brevity in your answer.  1.13. What is the ratio of the Pupil-teacher ratio(headcount basis) in Morocco in 1982 to that in 1986?
Make the answer very short. 1.3. What is the ratio of the Pupil-teacher ratio(headcount basis) in San Marino in 1982 to that in 1986?
Offer a terse response. 1.04. What is the ratio of the Pupil-teacher ratio(headcount basis) in Middle East & North Africa (developing only) in 1983 to that in 1984?
Give a very brief answer. 1.01. What is the ratio of the Pupil-teacher ratio(headcount basis) of Iraq in 1983 to that in 1984?
Offer a terse response. 1.02. What is the ratio of the Pupil-teacher ratio(headcount basis) of Morocco in 1983 to that in 1984?
Ensure brevity in your answer.  1.05. What is the ratio of the Pupil-teacher ratio(headcount basis) of San Marino in 1983 to that in 1984?
Give a very brief answer. 1.03. What is the ratio of the Pupil-teacher ratio(headcount basis) of Middle East & North Africa (developing only) in 1983 to that in 1985?
Your answer should be very brief. 1.03. What is the ratio of the Pupil-teacher ratio(headcount basis) in Iraq in 1983 to that in 1985?
Ensure brevity in your answer.  1.02. What is the ratio of the Pupil-teacher ratio(headcount basis) in Morocco in 1983 to that in 1985?
Offer a very short reply. 1.31. What is the ratio of the Pupil-teacher ratio(headcount basis) in San Marino in 1983 to that in 1985?
Offer a very short reply. 1.08. What is the ratio of the Pupil-teacher ratio(headcount basis) in Middle East & North Africa (developing only) in 1983 to that in 1986?
Your response must be concise. 1.02. What is the ratio of the Pupil-teacher ratio(headcount basis) of Iraq in 1983 to that in 1986?
Offer a very short reply. 1.03. What is the ratio of the Pupil-teacher ratio(headcount basis) of Morocco in 1983 to that in 1986?
Your answer should be compact. 1.3. What is the ratio of the Pupil-teacher ratio(headcount basis) of San Marino in 1983 to that in 1986?
Offer a terse response. 1.02. What is the ratio of the Pupil-teacher ratio(headcount basis) in Middle East & North Africa (developing only) in 1984 to that in 1985?
Make the answer very short. 1.02. What is the ratio of the Pupil-teacher ratio(headcount basis) of Iraq in 1984 to that in 1985?
Keep it short and to the point. 1.01. What is the ratio of the Pupil-teacher ratio(headcount basis) in Morocco in 1984 to that in 1985?
Provide a short and direct response. 1.25. What is the ratio of the Pupil-teacher ratio(headcount basis) in San Marino in 1984 to that in 1985?
Provide a short and direct response. 1.05. What is the ratio of the Pupil-teacher ratio(headcount basis) of Middle East & North Africa (developing only) in 1984 to that in 1986?
Offer a very short reply. 1.02. What is the ratio of the Pupil-teacher ratio(headcount basis) of Iraq in 1984 to that in 1986?
Your response must be concise. 1.01. What is the ratio of the Pupil-teacher ratio(headcount basis) of Morocco in 1984 to that in 1986?
Ensure brevity in your answer.  1.24. What is the ratio of the Pupil-teacher ratio(headcount basis) in San Marino in 1984 to that in 1986?
Make the answer very short. 0.99. What is the ratio of the Pupil-teacher ratio(headcount basis) in Middle East & North Africa (developing only) in 1985 to that in 1986?
Offer a very short reply. 1. What is the ratio of the Pupil-teacher ratio(headcount basis) of Iraq in 1985 to that in 1986?
Give a very brief answer. 1. What is the ratio of the Pupil-teacher ratio(headcount basis) of Morocco in 1985 to that in 1986?
Ensure brevity in your answer.  0.99. What is the ratio of the Pupil-teacher ratio(headcount basis) of San Marino in 1985 to that in 1986?
Offer a terse response. 0.94. What is the difference between the highest and the second highest Pupil-teacher ratio(headcount basis) in Middle East & North Africa (developing only)?
Provide a short and direct response. 0.72. What is the difference between the highest and the second highest Pupil-teacher ratio(headcount basis) of Iraq?
Give a very brief answer. 1.04. What is the difference between the highest and the second highest Pupil-teacher ratio(headcount basis) of Morocco?
Offer a very short reply. 1.9. What is the difference between the highest and the second highest Pupil-teacher ratio(headcount basis) of San Marino?
Your response must be concise. 1.11. What is the difference between the highest and the lowest Pupil-teacher ratio(headcount basis) in Middle East & North Africa (developing only)?
Offer a very short reply. 4.7. What is the difference between the highest and the lowest Pupil-teacher ratio(headcount basis) of Iraq?
Your answer should be compact. 4.05. What is the difference between the highest and the lowest Pupil-teacher ratio(headcount basis) of Morocco?
Ensure brevity in your answer.  10.68. What is the difference between the highest and the lowest Pupil-teacher ratio(headcount basis) in San Marino?
Provide a short and direct response. 1.99. 